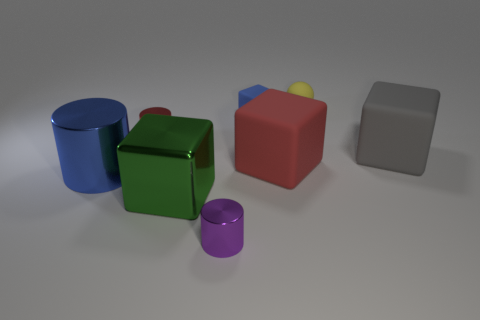Can you describe the shapes and colors of the objects in the image? Certainly! The image shows a collection of geometric solids. There's a blue cylinder, a green cube, a red cube, a small purple cylinder, a yellow sphere, and a gray rectangular prism. They are arranged on a flat surface, displaying a variety of shapes and colors commonly seen in basic geometry sets. 